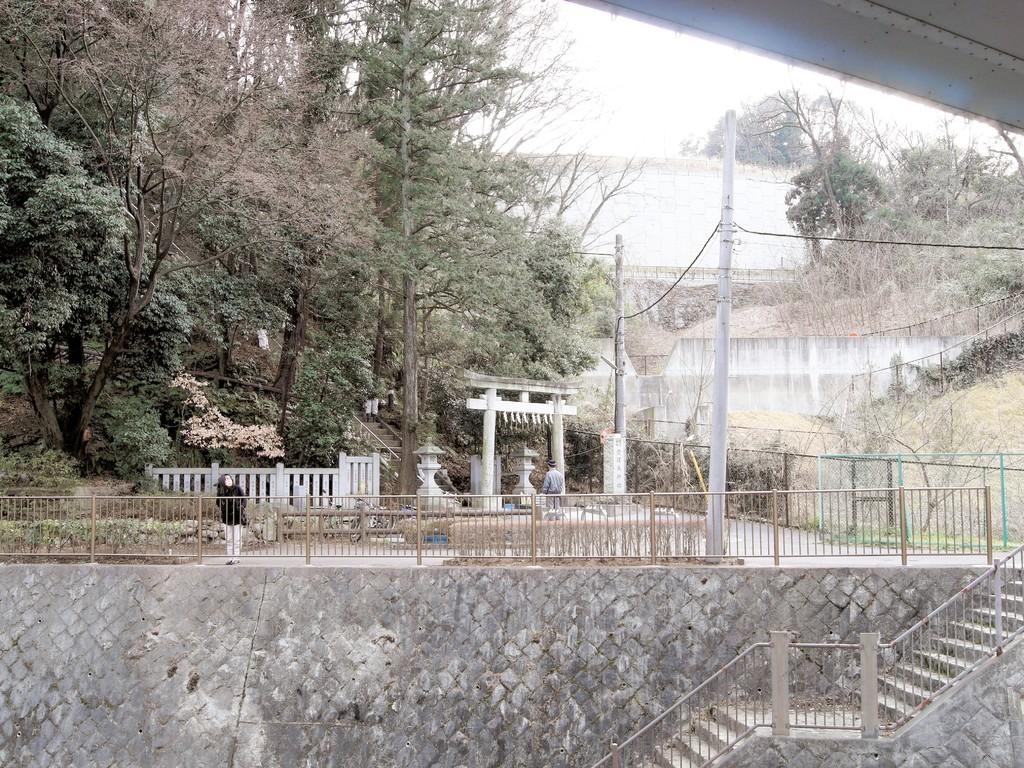What type of structure is present in the image? There is a wall with stairs in the image. What architectural elements can be seen in the image? There are pillars in the image. What type of barrier is visible in the image? There is a fence in the image. What are the poles used for in the image? Wires are tied to the poles in the image. What type of vegetation is present in the image? There are trees and grass in the image. Are there any people in the image? Yes, there are persons in the image. What can be seen in the sky in the image? The sky is visible in the image. What is the rate of snowfall in the image? There is no snowfall present in the image, so it is not possible to determine a rate. What type of park is visible in the image? There is no park present in the image; it features a wall with stairs, pillars, a fence, poles with wires, trees, grass, and persons. 